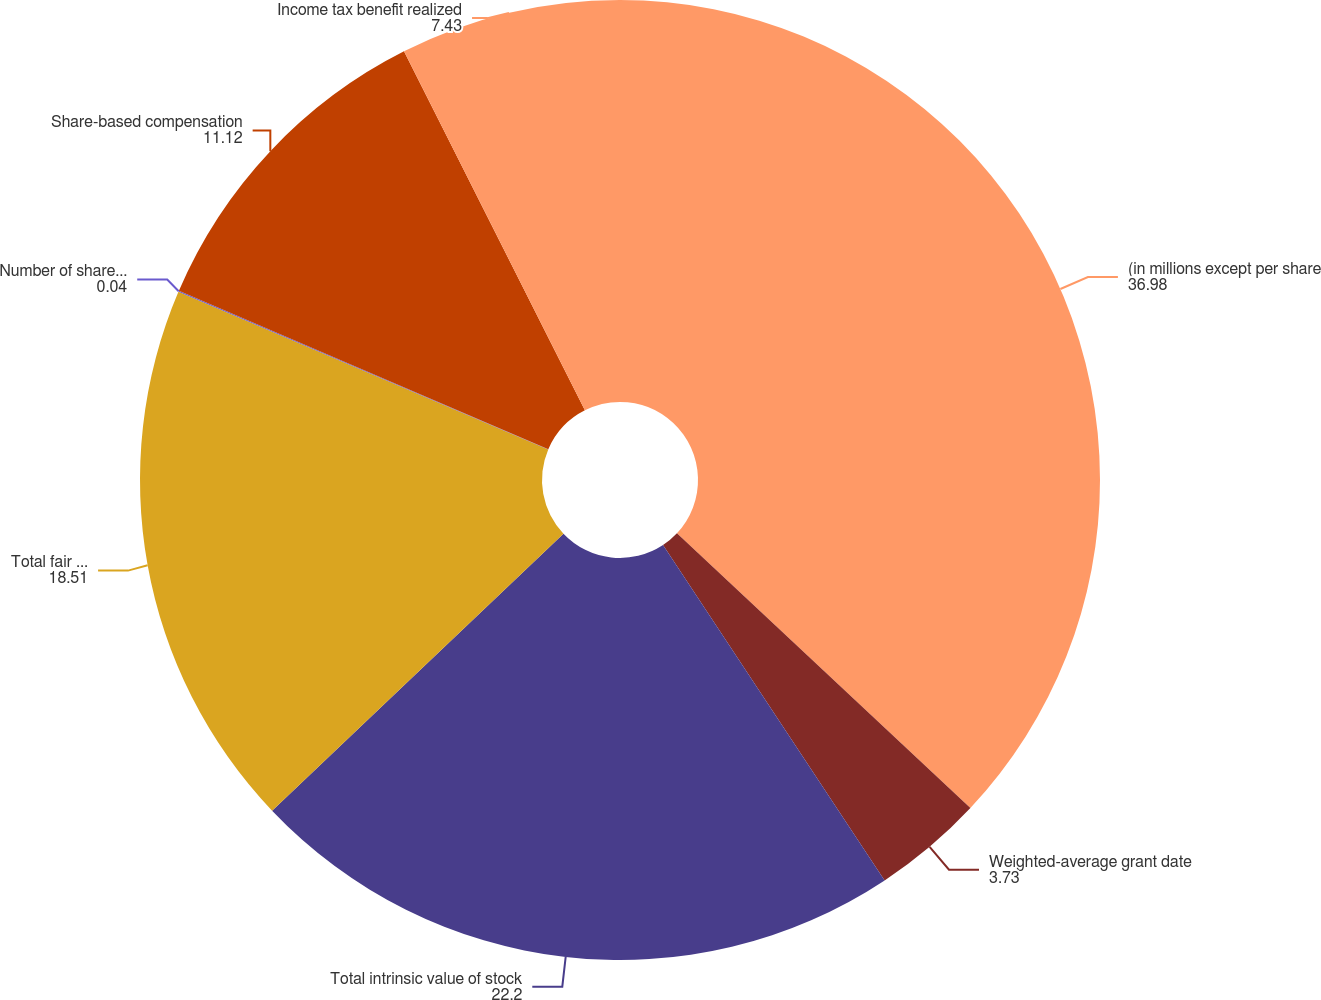Convert chart to OTSL. <chart><loc_0><loc_0><loc_500><loc_500><pie_chart><fcel>(in millions except per share<fcel>Weighted-average grant date<fcel>Total intrinsic value of stock<fcel>Total fair value of restricted<fcel>Number of shares purchased<fcel>Share-based compensation<fcel>Income tax benefit realized<nl><fcel>36.98%<fcel>3.73%<fcel>22.2%<fcel>18.51%<fcel>0.04%<fcel>11.12%<fcel>7.43%<nl></chart> 